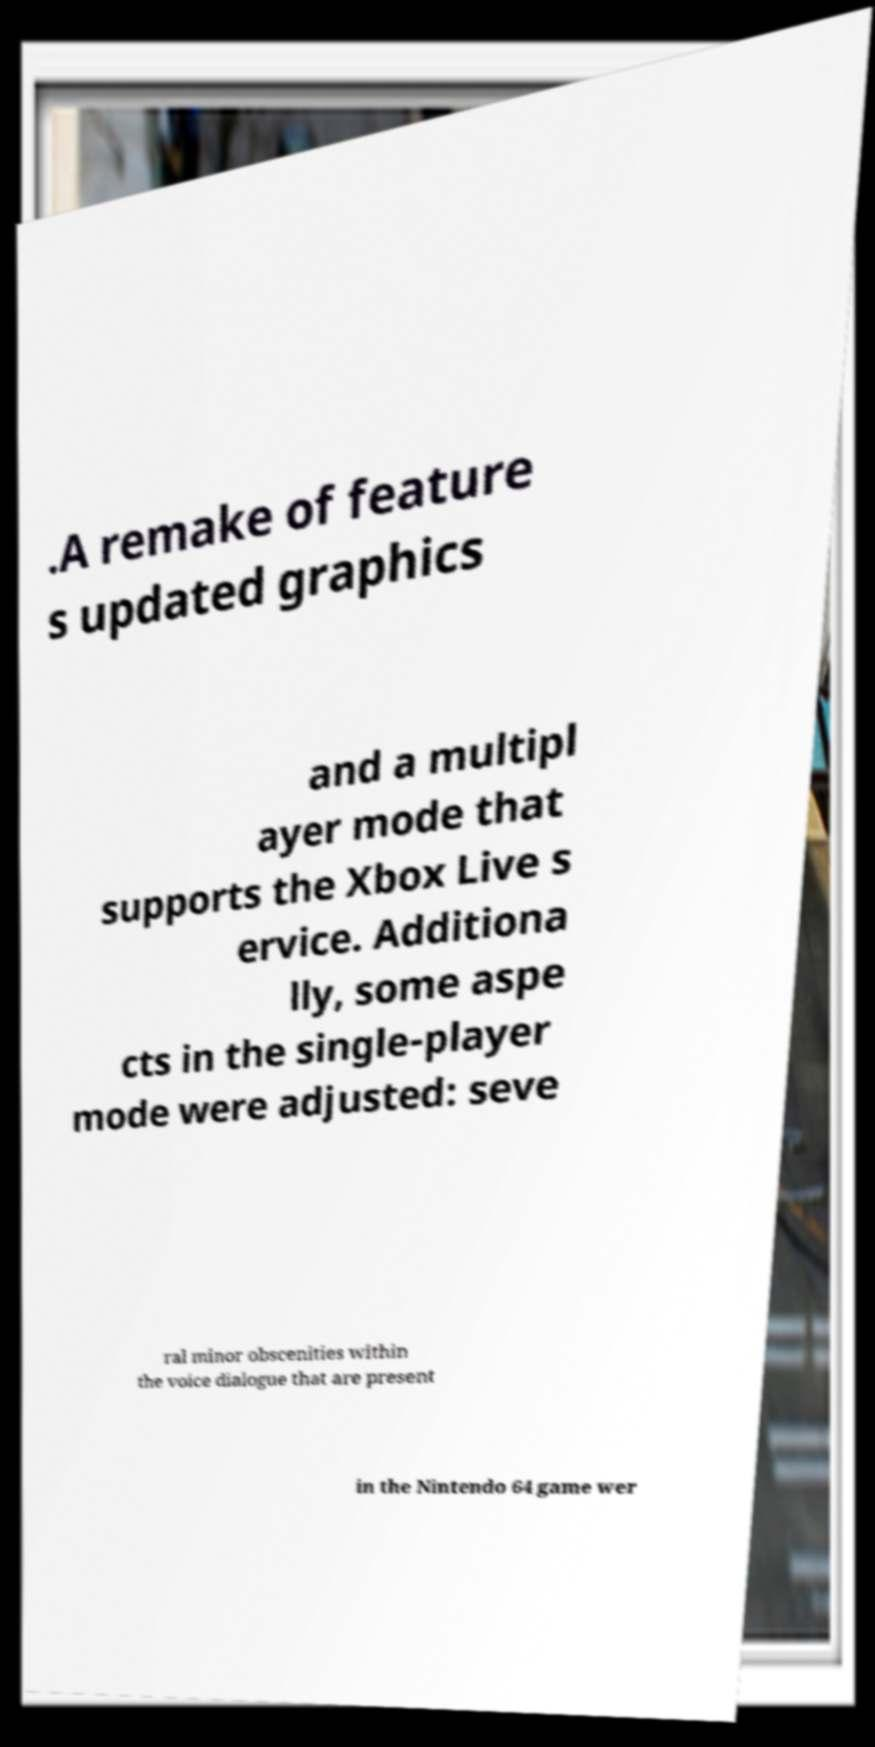What messages or text are displayed in this image? I need them in a readable, typed format. .A remake of feature s updated graphics and a multipl ayer mode that supports the Xbox Live s ervice. Additiona lly, some aspe cts in the single-player mode were adjusted: seve ral minor obscenities within the voice dialogue that are present in the Nintendo 64 game wer 